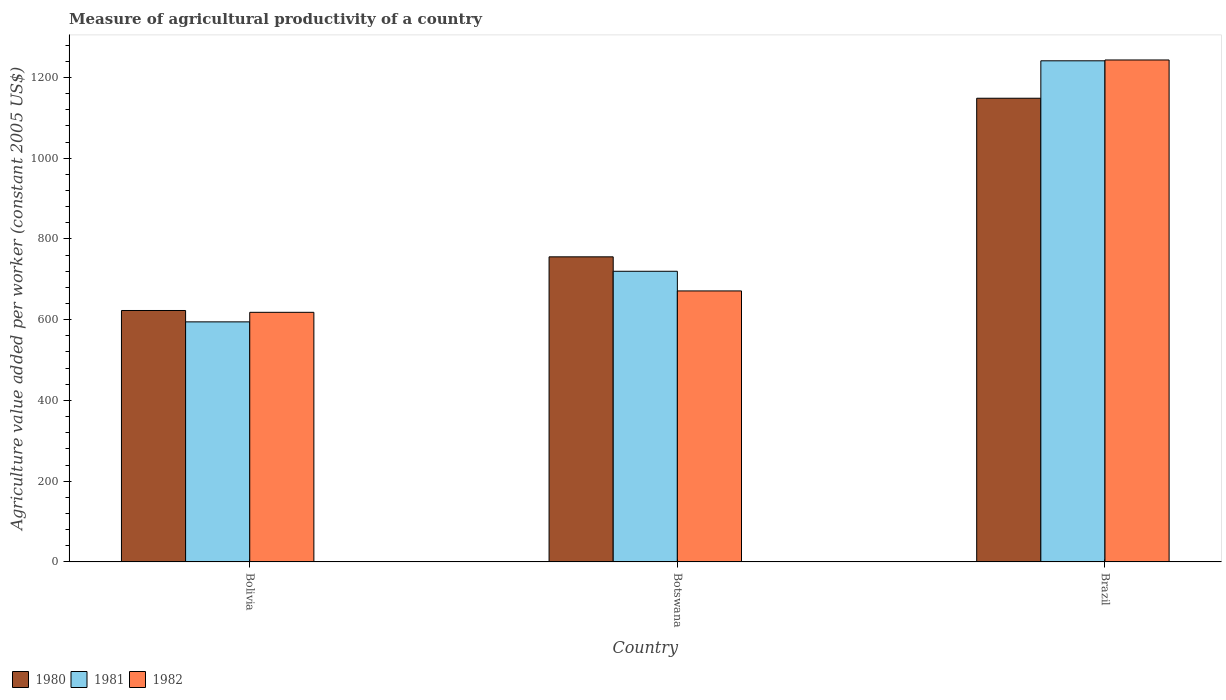Are the number of bars per tick equal to the number of legend labels?
Provide a short and direct response. Yes. How many bars are there on the 2nd tick from the left?
Your response must be concise. 3. How many bars are there on the 3rd tick from the right?
Provide a succinct answer. 3. What is the label of the 1st group of bars from the left?
Keep it short and to the point. Bolivia. What is the measure of agricultural productivity in 1982 in Bolivia?
Offer a terse response. 618.22. Across all countries, what is the maximum measure of agricultural productivity in 1982?
Provide a short and direct response. 1243.26. Across all countries, what is the minimum measure of agricultural productivity in 1981?
Make the answer very short. 594.58. What is the total measure of agricultural productivity in 1982 in the graph?
Make the answer very short. 2532.66. What is the difference between the measure of agricultural productivity in 1981 in Bolivia and that in Brazil?
Give a very brief answer. -646.62. What is the difference between the measure of agricultural productivity in 1980 in Botswana and the measure of agricultural productivity in 1981 in Bolivia?
Give a very brief answer. 161.07. What is the average measure of agricultural productivity in 1982 per country?
Your answer should be compact. 844.22. What is the difference between the measure of agricultural productivity of/in 1980 and measure of agricultural productivity of/in 1981 in Brazil?
Your response must be concise. -92.75. In how many countries, is the measure of agricultural productivity in 1982 greater than 640 US$?
Keep it short and to the point. 2. What is the ratio of the measure of agricultural productivity in 1980 in Bolivia to that in Botswana?
Provide a succinct answer. 0.82. Is the measure of agricultural productivity in 1981 in Bolivia less than that in Botswana?
Provide a succinct answer. Yes. What is the difference between the highest and the second highest measure of agricultural productivity in 1980?
Your answer should be very brief. -392.8. What is the difference between the highest and the lowest measure of agricultural productivity in 1982?
Provide a short and direct response. 625.04. In how many countries, is the measure of agricultural productivity in 1982 greater than the average measure of agricultural productivity in 1982 taken over all countries?
Offer a very short reply. 1. Is the sum of the measure of agricultural productivity in 1980 in Bolivia and Botswana greater than the maximum measure of agricultural productivity in 1982 across all countries?
Provide a succinct answer. Yes. What does the 1st bar from the right in Bolivia represents?
Make the answer very short. 1982. Is it the case that in every country, the sum of the measure of agricultural productivity in 1981 and measure of agricultural productivity in 1982 is greater than the measure of agricultural productivity in 1980?
Make the answer very short. Yes. How many bars are there?
Your answer should be very brief. 9. Are all the bars in the graph horizontal?
Your answer should be very brief. No. How many countries are there in the graph?
Provide a short and direct response. 3. What is the difference between two consecutive major ticks on the Y-axis?
Your answer should be very brief. 200. Are the values on the major ticks of Y-axis written in scientific E-notation?
Provide a short and direct response. No. Where does the legend appear in the graph?
Provide a succinct answer. Bottom left. What is the title of the graph?
Your answer should be compact. Measure of agricultural productivity of a country. What is the label or title of the Y-axis?
Provide a succinct answer. Agriculture value added per worker (constant 2005 US$). What is the Agriculture value added per worker (constant 2005 US$) of 1980 in Bolivia?
Make the answer very short. 622.75. What is the Agriculture value added per worker (constant 2005 US$) of 1981 in Bolivia?
Provide a succinct answer. 594.58. What is the Agriculture value added per worker (constant 2005 US$) of 1982 in Bolivia?
Your response must be concise. 618.22. What is the Agriculture value added per worker (constant 2005 US$) of 1980 in Botswana?
Offer a terse response. 755.65. What is the Agriculture value added per worker (constant 2005 US$) in 1981 in Botswana?
Give a very brief answer. 719.89. What is the Agriculture value added per worker (constant 2005 US$) of 1982 in Botswana?
Provide a short and direct response. 671.18. What is the Agriculture value added per worker (constant 2005 US$) of 1980 in Brazil?
Keep it short and to the point. 1148.46. What is the Agriculture value added per worker (constant 2005 US$) of 1981 in Brazil?
Make the answer very short. 1241.2. What is the Agriculture value added per worker (constant 2005 US$) of 1982 in Brazil?
Make the answer very short. 1243.26. Across all countries, what is the maximum Agriculture value added per worker (constant 2005 US$) of 1980?
Offer a terse response. 1148.46. Across all countries, what is the maximum Agriculture value added per worker (constant 2005 US$) of 1981?
Your response must be concise. 1241.2. Across all countries, what is the maximum Agriculture value added per worker (constant 2005 US$) of 1982?
Your answer should be very brief. 1243.26. Across all countries, what is the minimum Agriculture value added per worker (constant 2005 US$) in 1980?
Offer a very short reply. 622.75. Across all countries, what is the minimum Agriculture value added per worker (constant 2005 US$) in 1981?
Provide a short and direct response. 594.58. Across all countries, what is the minimum Agriculture value added per worker (constant 2005 US$) in 1982?
Give a very brief answer. 618.22. What is the total Agriculture value added per worker (constant 2005 US$) in 1980 in the graph?
Your answer should be very brief. 2526.86. What is the total Agriculture value added per worker (constant 2005 US$) in 1981 in the graph?
Your response must be concise. 2555.67. What is the total Agriculture value added per worker (constant 2005 US$) of 1982 in the graph?
Make the answer very short. 2532.66. What is the difference between the Agriculture value added per worker (constant 2005 US$) of 1980 in Bolivia and that in Botswana?
Provide a short and direct response. -132.9. What is the difference between the Agriculture value added per worker (constant 2005 US$) of 1981 in Bolivia and that in Botswana?
Provide a short and direct response. -125.3. What is the difference between the Agriculture value added per worker (constant 2005 US$) of 1982 in Bolivia and that in Botswana?
Provide a succinct answer. -52.96. What is the difference between the Agriculture value added per worker (constant 2005 US$) of 1980 in Bolivia and that in Brazil?
Provide a short and direct response. -525.7. What is the difference between the Agriculture value added per worker (constant 2005 US$) in 1981 in Bolivia and that in Brazil?
Give a very brief answer. -646.62. What is the difference between the Agriculture value added per worker (constant 2005 US$) of 1982 in Bolivia and that in Brazil?
Keep it short and to the point. -625.04. What is the difference between the Agriculture value added per worker (constant 2005 US$) in 1980 in Botswana and that in Brazil?
Your response must be concise. -392.8. What is the difference between the Agriculture value added per worker (constant 2005 US$) in 1981 in Botswana and that in Brazil?
Keep it short and to the point. -521.32. What is the difference between the Agriculture value added per worker (constant 2005 US$) in 1982 in Botswana and that in Brazil?
Ensure brevity in your answer.  -572.08. What is the difference between the Agriculture value added per worker (constant 2005 US$) of 1980 in Bolivia and the Agriculture value added per worker (constant 2005 US$) of 1981 in Botswana?
Your response must be concise. -97.14. What is the difference between the Agriculture value added per worker (constant 2005 US$) of 1980 in Bolivia and the Agriculture value added per worker (constant 2005 US$) of 1982 in Botswana?
Offer a terse response. -48.43. What is the difference between the Agriculture value added per worker (constant 2005 US$) of 1981 in Bolivia and the Agriculture value added per worker (constant 2005 US$) of 1982 in Botswana?
Provide a succinct answer. -76.6. What is the difference between the Agriculture value added per worker (constant 2005 US$) of 1980 in Bolivia and the Agriculture value added per worker (constant 2005 US$) of 1981 in Brazil?
Ensure brevity in your answer.  -618.45. What is the difference between the Agriculture value added per worker (constant 2005 US$) in 1980 in Bolivia and the Agriculture value added per worker (constant 2005 US$) in 1982 in Brazil?
Your response must be concise. -620.51. What is the difference between the Agriculture value added per worker (constant 2005 US$) of 1981 in Bolivia and the Agriculture value added per worker (constant 2005 US$) of 1982 in Brazil?
Give a very brief answer. -648.68. What is the difference between the Agriculture value added per worker (constant 2005 US$) in 1980 in Botswana and the Agriculture value added per worker (constant 2005 US$) in 1981 in Brazil?
Make the answer very short. -485.55. What is the difference between the Agriculture value added per worker (constant 2005 US$) of 1980 in Botswana and the Agriculture value added per worker (constant 2005 US$) of 1982 in Brazil?
Make the answer very short. -487.61. What is the difference between the Agriculture value added per worker (constant 2005 US$) in 1981 in Botswana and the Agriculture value added per worker (constant 2005 US$) in 1982 in Brazil?
Provide a succinct answer. -523.37. What is the average Agriculture value added per worker (constant 2005 US$) in 1980 per country?
Offer a terse response. 842.29. What is the average Agriculture value added per worker (constant 2005 US$) in 1981 per country?
Ensure brevity in your answer.  851.89. What is the average Agriculture value added per worker (constant 2005 US$) in 1982 per country?
Your answer should be very brief. 844.22. What is the difference between the Agriculture value added per worker (constant 2005 US$) of 1980 and Agriculture value added per worker (constant 2005 US$) of 1981 in Bolivia?
Ensure brevity in your answer.  28.17. What is the difference between the Agriculture value added per worker (constant 2005 US$) in 1980 and Agriculture value added per worker (constant 2005 US$) in 1982 in Bolivia?
Your answer should be very brief. 4.53. What is the difference between the Agriculture value added per worker (constant 2005 US$) in 1981 and Agriculture value added per worker (constant 2005 US$) in 1982 in Bolivia?
Your answer should be compact. -23.63. What is the difference between the Agriculture value added per worker (constant 2005 US$) in 1980 and Agriculture value added per worker (constant 2005 US$) in 1981 in Botswana?
Your answer should be very brief. 35.77. What is the difference between the Agriculture value added per worker (constant 2005 US$) in 1980 and Agriculture value added per worker (constant 2005 US$) in 1982 in Botswana?
Offer a terse response. 84.47. What is the difference between the Agriculture value added per worker (constant 2005 US$) of 1981 and Agriculture value added per worker (constant 2005 US$) of 1982 in Botswana?
Offer a very short reply. 48.71. What is the difference between the Agriculture value added per worker (constant 2005 US$) in 1980 and Agriculture value added per worker (constant 2005 US$) in 1981 in Brazil?
Make the answer very short. -92.75. What is the difference between the Agriculture value added per worker (constant 2005 US$) in 1980 and Agriculture value added per worker (constant 2005 US$) in 1982 in Brazil?
Make the answer very short. -94.81. What is the difference between the Agriculture value added per worker (constant 2005 US$) in 1981 and Agriculture value added per worker (constant 2005 US$) in 1982 in Brazil?
Your answer should be very brief. -2.06. What is the ratio of the Agriculture value added per worker (constant 2005 US$) in 1980 in Bolivia to that in Botswana?
Ensure brevity in your answer.  0.82. What is the ratio of the Agriculture value added per worker (constant 2005 US$) in 1981 in Bolivia to that in Botswana?
Your response must be concise. 0.83. What is the ratio of the Agriculture value added per worker (constant 2005 US$) of 1982 in Bolivia to that in Botswana?
Your answer should be compact. 0.92. What is the ratio of the Agriculture value added per worker (constant 2005 US$) of 1980 in Bolivia to that in Brazil?
Your answer should be very brief. 0.54. What is the ratio of the Agriculture value added per worker (constant 2005 US$) in 1981 in Bolivia to that in Brazil?
Your answer should be compact. 0.48. What is the ratio of the Agriculture value added per worker (constant 2005 US$) in 1982 in Bolivia to that in Brazil?
Ensure brevity in your answer.  0.5. What is the ratio of the Agriculture value added per worker (constant 2005 US$) of 1980 in Botswana to that in Brazil?
Your answer should be compact. 0.66. What is the ratio of the Agriculture value added per worker (constant 2005 US$) in 1981 in Botswana to that in Brazil?
Make the answer very short. 0.58. What is the ratio of the Agriculture value added per worker (constant 2005 US$) of 1982 in Botswana to that in Brazil?
Ensure brevity in your answer.  0.54. What is the difference between the highest and the second highest Agriculture value added per worker (constant 2005 US$) in 1980?
Make the answer very short. 392.8. What is the difference between the highest and the second highest Agriculture value added per worker (constant 2005 US$) in 1981?
Keep it short and to the point. 521.32. What is the difference between the highest and the second highest Agriculture value added per worker (constant 2005 US$) of 1982?
Keep it short and to the point. 572.08. What is the difference between the highest and the lowest Agriculture value added per worker (constant 2005 US$) of 1980?
Keep it short and to the point. 525.7. What is the difference between the highest and the lowest Agriculture value added per worker (constant 2005 US$) of 1981?
Your response must be concise. 646.62. What is the difference between the highest and the lowest Agriculture value added per worker (constant 2005 US$) in 1982?
Your response must be concise. 625.04. 